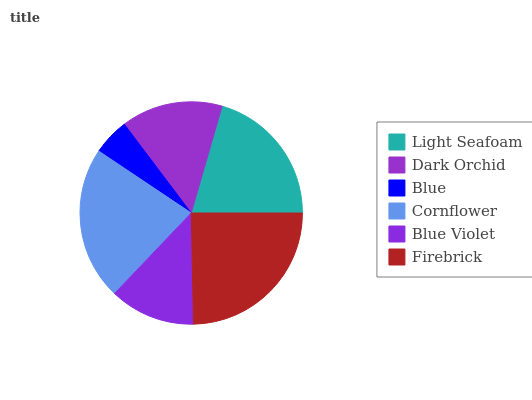Is Blue the minimum?
Answer yes or no. Yes. Is Firebrick the maximum?
Answer yes or no. Yes. Is Dark Orchid the minimum?
Answer yes or no. No. Is Dark Orchid the maximum?
Answer yes or no. No. Is Light Seafoam greater than Dark Orchid?
Answer yes or no. Yes. Is Dark Orchid less than Light Seafoam?
Answer yes or no. Yes. Is Dark Orchid greater than Light Seafoam?
Answer yes or no. No. Is Light Seafoam less than Dark Orchid?
Answer yes or no. No. Is Light Seafoam the high median?
Answer yes or no. Yes. Is Dark Orchid the low median?
Answer yes or no. Yes. Is Cornflower the high median?
Answer yes or no. No. Is Firebrick the low median?
Answer yes or no. No. 